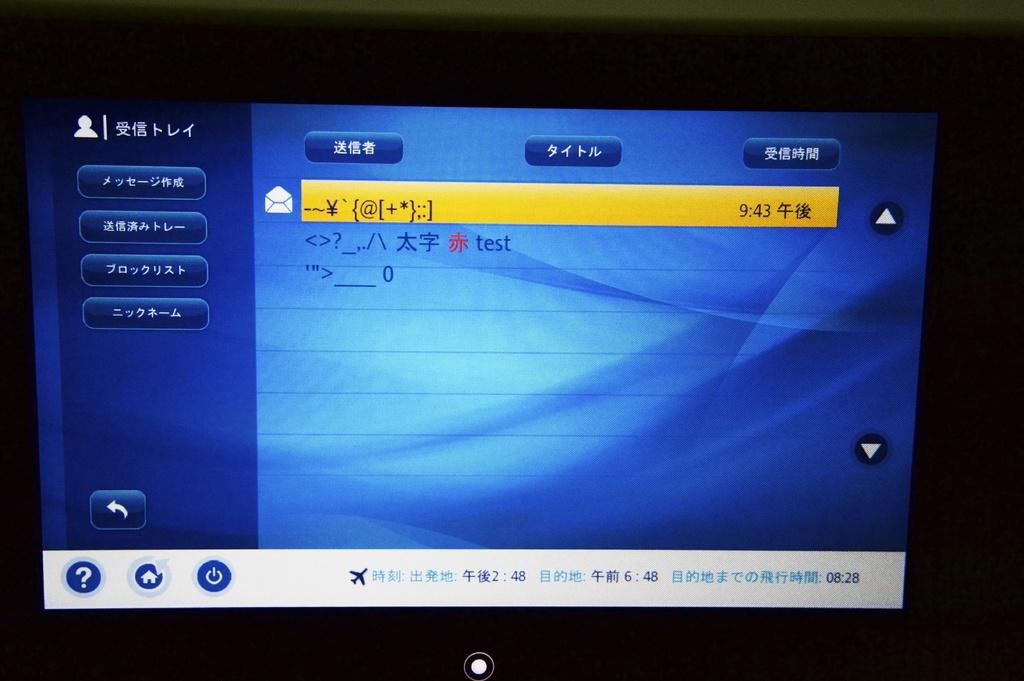<image>
Describe the image concisely. Computer screen showing the word test next to a chinese symbol. 